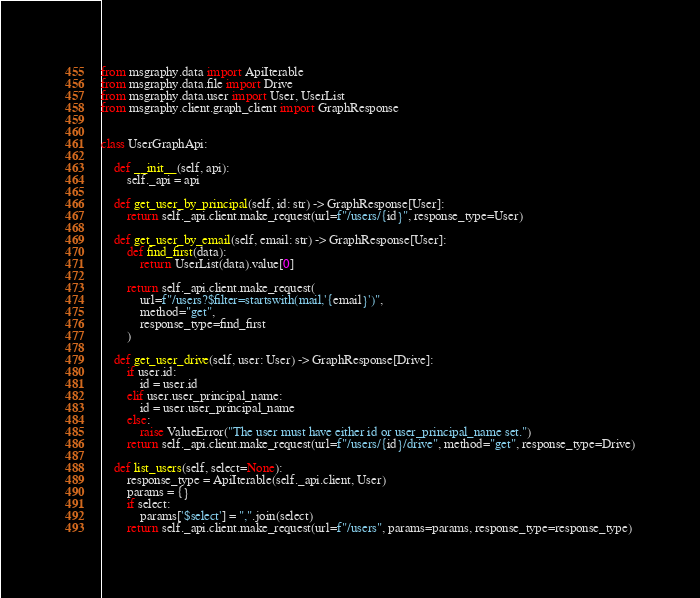Convert code to text. <code><loc_0><loc_0><loc_500><loc_500><_Python_>from msgraphy.data import ApiIterable
from msgraphy.data.file import Drive
from msgraphy.data.user import User, UserList
from msgraphy.client.graph_client import GraphResponse


class UserGraphApi:

    def __init__(self, api):
        self._api = api

    def get_user_by_principal(self, id: str) -> GraphResponse[User]:
        return self._api.client.make_request(url=f"/users/{id}", response_type=User)

    def get_user_by_email(self, email: str) -> GraphResponse[User]:
        def find_first(data):
            return UserList(data).value[0]

        return self._api.client.make_request(
            url=f"/users?$filter=startswith(mail,'{email}')",
            method="get",
            response_type=find_first
        )

    def get_user_drive(self, user: User) -> GraphResponse[Drive]:
        if user.id:
            id = user.id
        elif user.user_principal_name:
            id = user.user_principal_name
        else:
            raise ValueError("The user must have either id or user_principal_name set.")
        return self._api.client.make_request(url=f"/users/{id}/drive", method="get", response_type=Drive)

    def list_users(self, select=None):
        response_type = ApiIterable(self._api.client, User)
        params = {}
        if select:
            params['$select'] = ",".join(select)
        return self._api.client.make_request(url=f"/users", params=params, response_type=response_type)
</code> 